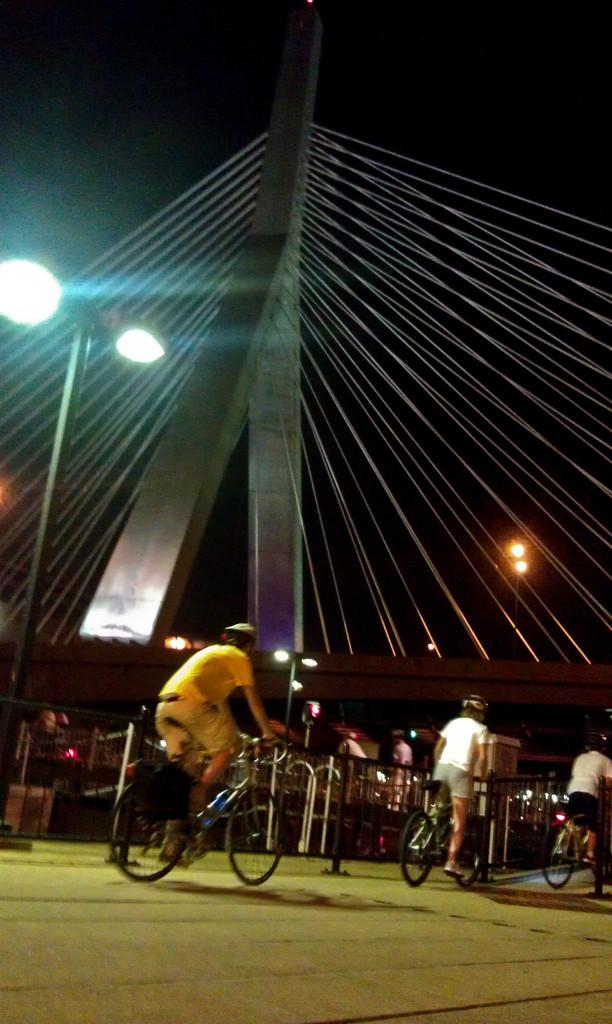What is visible at the top of the image? The sky is visible at the top of the image. How would you describe the appearance of the sky in the image? The sky appears dark in the image. What can be seen in the image besides the sky? There are lights and people riding bicycles in the image. What safety precaution are the people taking while riding bicycles? The people are wearing helmets while riding bicycles. What type of picture is hanging on the wall in the image? There is no mention of a wall or a picture hanging on it in the provided facts. 